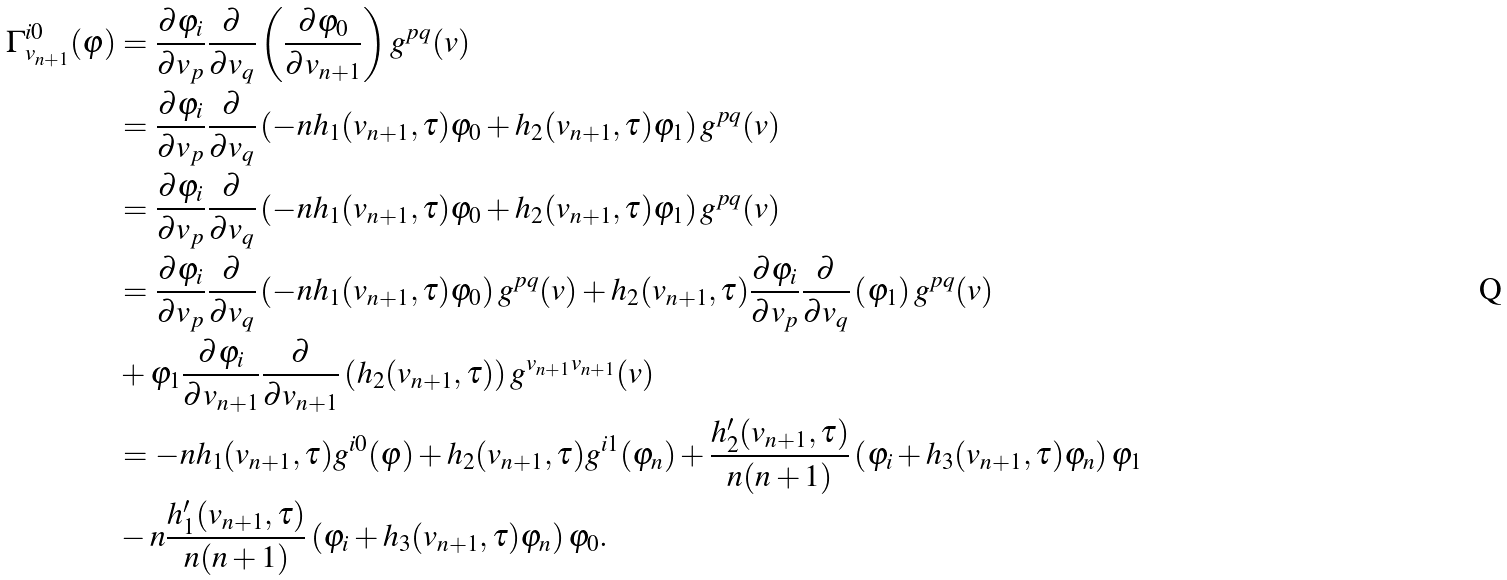<formula> <loc_0><loc_0><loc_500><loc_500>\Gamma _ { v _ { n + 1 } } ^ { i 0 } ( \varphi ) & = \frac { \partial \varphi _ { i } } { \partial v _ { p } } \frac { \partial } { \partial v _ { q } } \left ( \frac { \partial \varphi _ { 0 } } { \partial v _ { n + 1 } } \right ) g ^ { p q } ( v ) \\ & = \frac { \partial \varphi _ { i } } { \partial v _ { p } } \frac { \partial } { \partial v _ { q } } \left ( - n h _ { 1 } ( v _ { n + 1 } , \tau ) \varphi _ { 0 } + h _ { 2 } ( v _ { n + 1 } , \tau ) \varphi _ { 1 } \right ) g ^ { p q } ( v ) \\ & = \frac { \partial \varphi _ { i } } { \partial v _ { p } } \frac { \partial } { \partial v _ { q } } \left ( - n h _ { 1 } ( v _ { n + 1 } , \tau ) \varphi _ { 0 } + h _ { 2 } ( v _ { n + 1 } , \tau ) \varphi _ { 1 } \right ) g ^ { p q } ( v ) \\ & = \frac { \partial \varphi _ { i } } { \partial v _ { p } } \frac { \partial } { \partial v _ { q } } \left ( - n h _ { 1 } ( v _ { n + 1 } , \tau ) \varphi _ { 0 } \right ) g ^ { p q } ( v ) + h _ { 2 } ( v _ { n + 1 } , \tau ) \frac { \partial \varphi _ { i } } { \partial v _ { p } } \frac { \partial } { \partial v _ { q } } \left ( \varphi _ { 1 } \right ) g ^ { p q } ( v ) \\ & + \varphi _ { 1 } \frac { \partial \varphi _ { i } } { \partial v _ { n + 1 } } \frac { \partial } { \partial v _ { n + 1 } } \left ( h _ { 2 } ( v _ { n + 1 } , \tau ) \right ) g ^ { v _ { n + 1 } v _ { n + 1 } } ( v ) \\ & = - n h _ { 1 } ( v _ { n + 1 } , \tau ) g ^ { i 0 } ( \varphi ) + h _ { 2 } ( v _ { n + 1 } , \tau ) g ^ { i 1 } ( \varphi _ { n } ) + \frac { h _ { 2 } ^ { \prime } ( v _ { n + 1 } , \tau ) } { n ( n + 1 ) } \left ( \varphi _ { i } + h _ { 3 } ( v _ { n + 1 } , \tau ) \varphi _ { n } \right ) \varphi _ { 1 } \\ & - n \frac { h _ { 1 } ^ { \prime } ( v _ { n + 1 } , \tau ) } { n ( n + 1 ) } \left ( \varphi _ { i } + h _ { 3 } ( v _ { n + 1 } , \tau ) \varphi _ { n } \right ) \varphi _ { 0 } .</formula> 